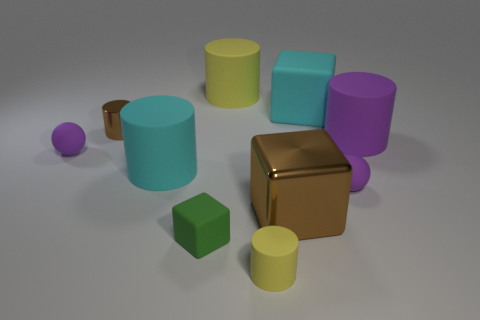Subtract all brown cylinders. Subtract all red blocks. How many cylinders are left? 4 Subtract all blocks. How many objects are left? 7 Add 7 large yellow rubber cylinders. How many large yellow rubber cylinders are left? 8 Add 8 big metal cylinders. How many big metal cylinders exist? 8 Subtract 1 brown cubes. How many objects are left? 9 Subtract all yellow cubes. Subtract all rubber objects. How many objects are left? 2 